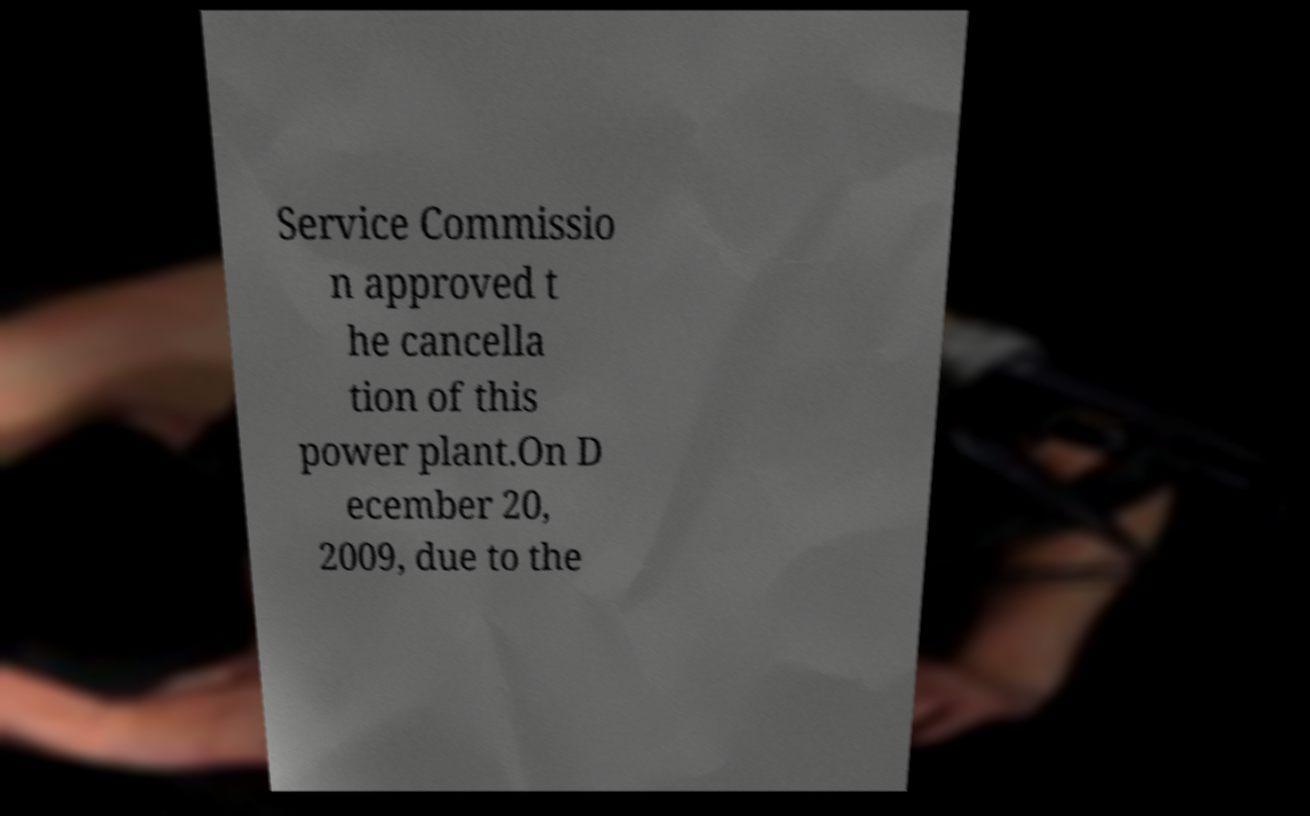Please read and relay the text visible in this image. What does it say? Service Commissio n approved t he cancella tion of this power plant.On D ecember 20, 2009, due to the 